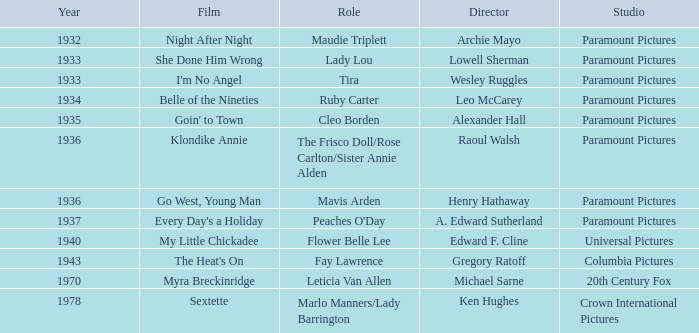What is the Year of the Film Belle of the Nineties? 1934.0. 